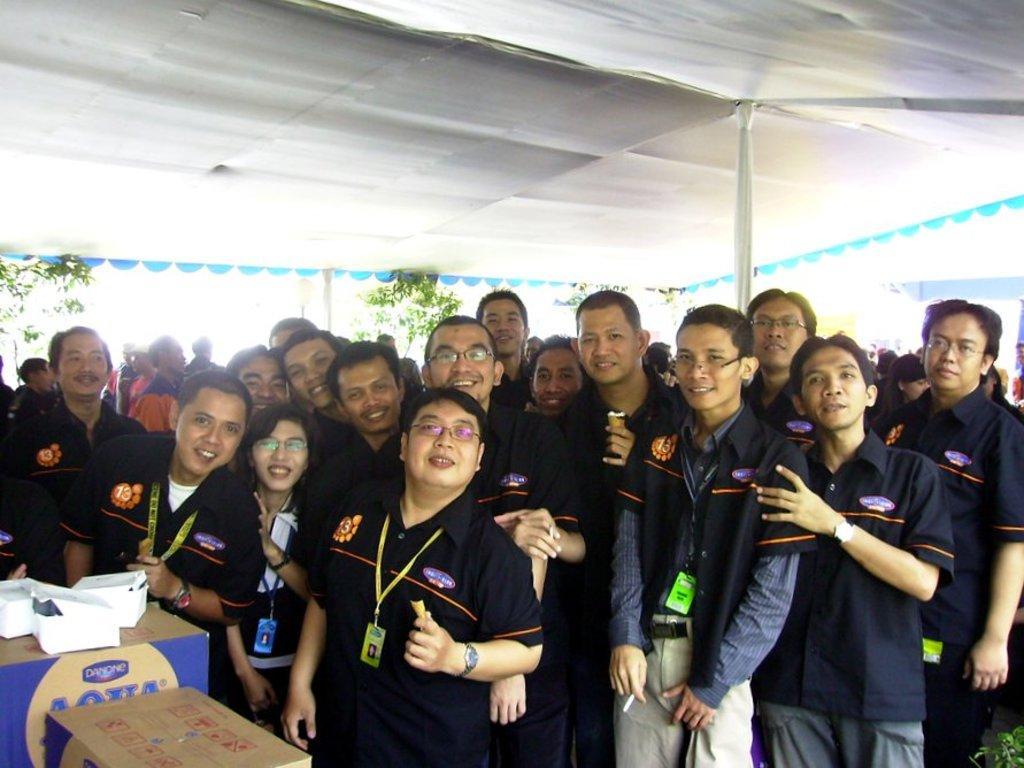Can you describe this image briefly? In this picture I can see there are a group of people standing here and they are smiling and there are plants in the backdrop. There are cartons into left and there is a tent here. 